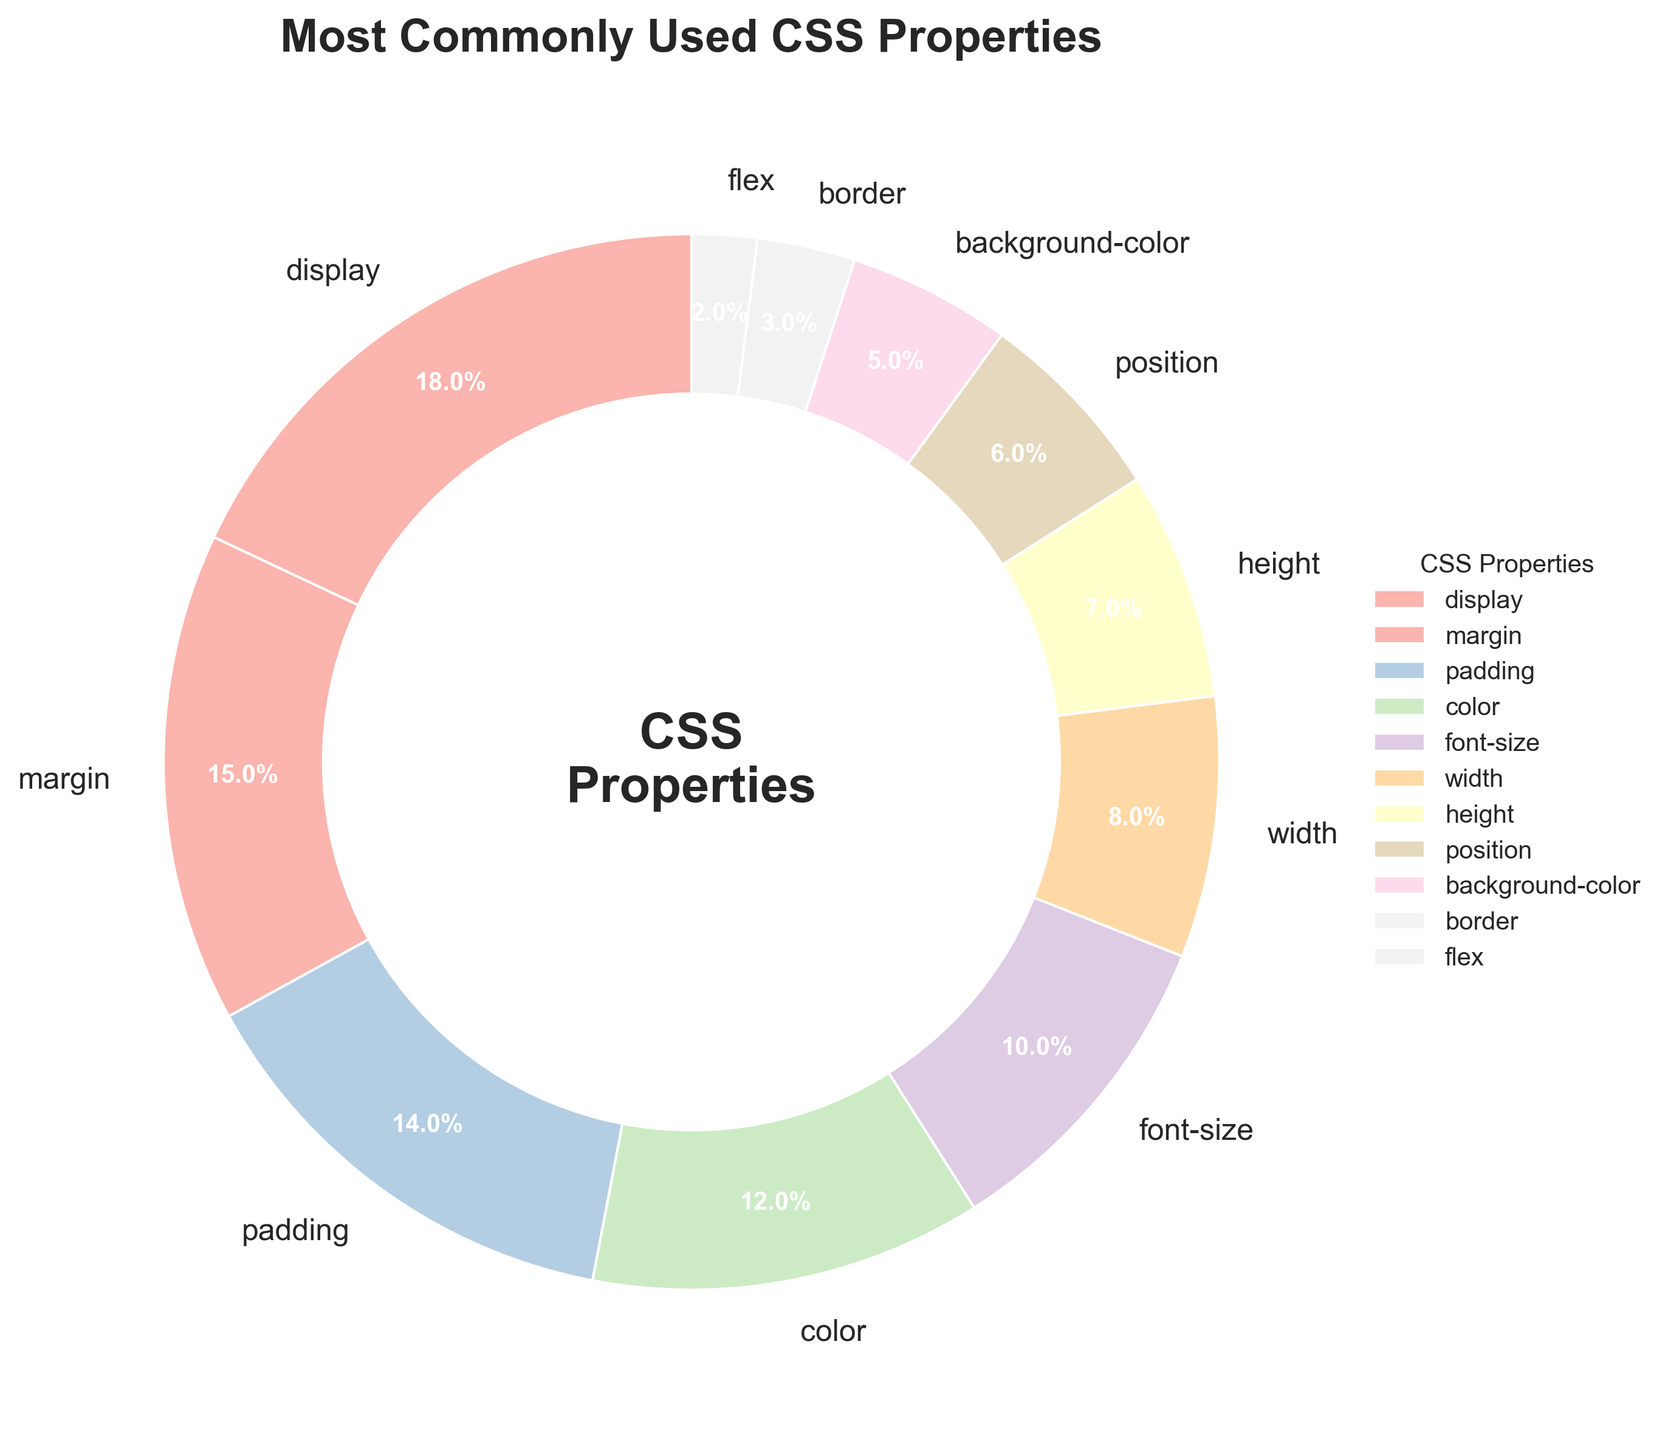What is the most commonly used CSS property, and what percentage of usage does it account for? The most commonly used CSS property can be identified by finding the property with the largest percentage in the pie chart. According to the chart, "display" has the largest wedge. The percentage is displayed within or near the wedge.
Answer: display, 18% Which CSS property has a usage rate of 10%? To answer this, we look at the pie chart and identify the wedge labeled with 10%. The chart shows that "font-size" is associated with 10% usage.
Answer: font-size How much more do developers use "margin" compared to "flex"? From the chart, determine the percentage use of "margin" and "flex," which are 15% and 2%, respectively. The difference is computed by subtracting the smaller percentage from the larger one. 15% - 2% = 13%.
Answer: 13% Which property has a lower usage rate: "position" or "height"? First, find the percentages of "position" and "height" from the pie chart, which are 6% and 7%, respectively. Then compare the two values. 6% is less than 7%.
Answer: position What is the combined percentage usage of "background-color" and "border"? Find the individual percentages for "background-color" and "border," which are 5% and 3%. Add these percentages together: 5% + 3% = 8%.
Answer: 8% How many CSS properties have a usage rate greater than or equal to 10%? Identify the properties in the pie chart with usage rates of 10% or more. These are "display" (18%), "margin" (15%), "padding" (14%), "color" (12%), and "font-size" (10%). Count them, which gives us five properties.
Answer: 5 Which CSS property wedge is visually the smallest in the pie chart, and what is its percentage? The smallest wedge can be observed directly from the chart. The "flex" property has the smallest wedge, with a usage rate of 2%.
Answer: flex, 2% Is the usage percentage of "width" greater than the combined percentage of "border" and "flex"? First, get the percentage for "width" (8%) and then the combined percentage for "border" (3%) and "flex" (2%). Adding "border" and "flex" gives 3% + 2% = 5%. 8% is greater than 5%.
Answer: Yes What is the total percentage usage of properties related to dimension (width, height) and position (position)? Identify the percentages for "width" (8%), "height" (7%), and "position" (6%). Add these percentages together: 8% + 7% + 6% = 21%.
Answer: 21% Which of the properties are used more frequently than "background-color" but less frequently than "padding"? Determine that "padding" has a 14% usage rate and "background-color" has 5%. The properties within this range are "color" (12%), "font-size" (10%), "width" (8%), and "height" (7%).
Answer: color, font-size, width, height 